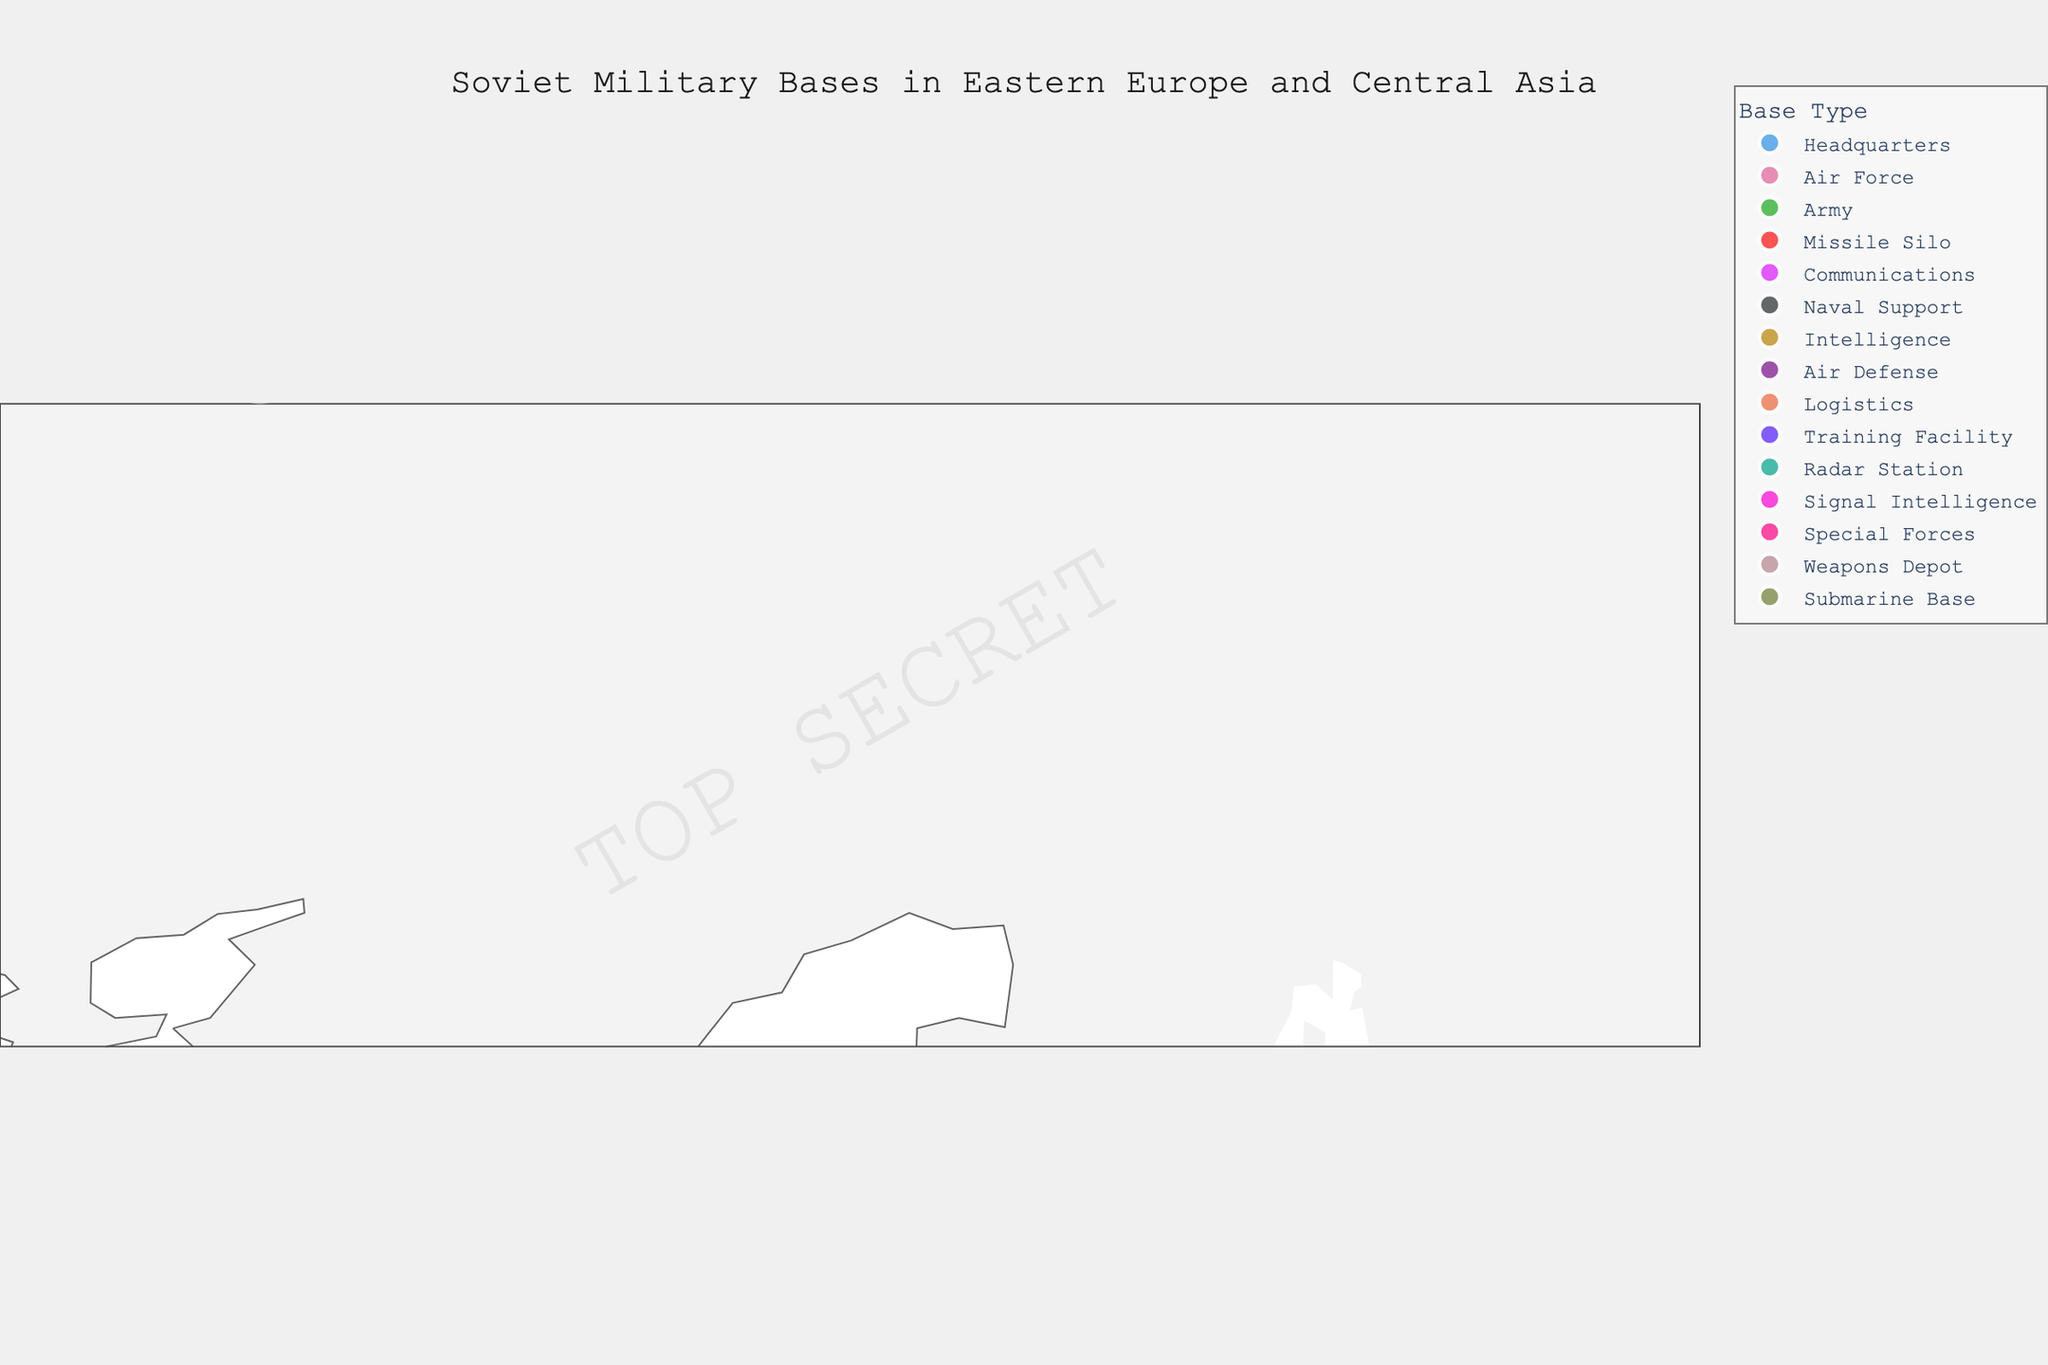Which city has the base with the highest number of personnel? To determine the city with the highest number of personnel, locate the data point with the largest circle, as the circle size correlates with personnel. The largest circle corresponds to Moscow, noted as the headquarters with 5000 personnel.
Answer: Moscow How many different types of military bases are visualized on the map? Each unique color represents a different type of military base. By counting the distinct colors and their corresponding labels in the legend, we get the total number of different base types. There are 14 different base types.
Answer: 14 Which base type is located the farthest east? To find the base located farthest to the east, look for the data point with the highest longitude value. Baku, with a submarine base, is the easternmost point with a longitude of 49.8671.
Answer: Submarine Base Which two bases are closest to each other geographically? Evaluate the latitudes and longitudes on the map and compare the distances between pairs of bases. Vilnius (54.6872, 25.2797) and Minsk (53.9006, 27.559) are the closest geographically.
Answer: Vilnius and Minsk What is the average number of personnel across all bases? Calculate the mean number of personnel by summing all personnel values and dividing by the number of bases. The total personnel is 28700 across 14 bases, so the average is 28700 / 14 = 2050.
Answer: 2050 Which region (easternmost or westernmost) has a higher accumulation of military bases? Count the number of bases by splitting the map roughly around the longitude midpoint (Longitude 50). The western region has more bases: Moscow, Kiev, Minsk, Warsaw, Prague, Bucharest, Sofia, Budapest, Riga, Vilnius.
Answer: Westernmost Are there more air-related bases or ground-related bases? Identify bases related to air (Air Force, Air Defense, Radar Station) and ground (Army, Missile Silo, Logistics, Training Facility). Air-related have 3 (Kiev, Bucharest, Riga) and ground-related have 4 (Minsk, Tashkent, Sofia, Budapest).
Answer: Ground-related What is the average number of personnel for the 'Air Force' bases? There is only one 'Air Force' base listed in the data located in Kiev with 3500 personnel. Since there is only one base, the average is 3500.
Answer: 3500 Which base type has the smallest number of personnel? Find the smallest circle on the map, which corresponds to the smallest number of personnel. The Radar Station in Riga has 400 personnel, the smallest among all the bases.
Answer: Radar Station Which city's base is the central point of the coordinate system's projection on the map? The map's center in the projection configuration is set to approximately latitude 50 and longitude 50. The closest city's base to this central point is Kiev.
Answer: Kiev 